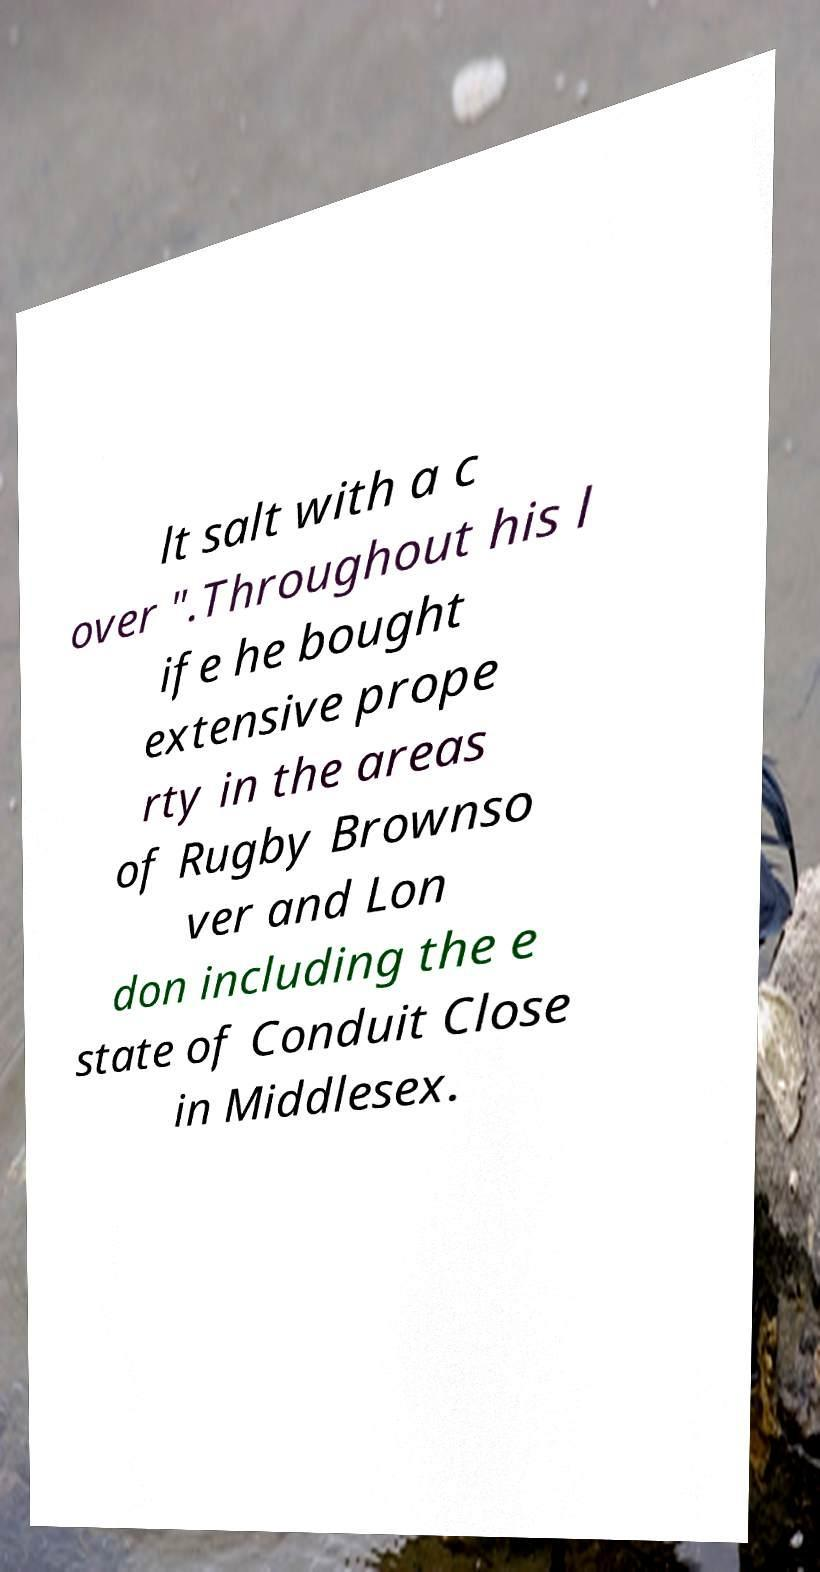For documentation purposes, I need the text within this image transcribed. Could you provide that? lt salt with a c over ".Throughout his l ife he bought extensive prope rty in the areas of Rugby Brownso ver and Lon don including the e state of Conduit Close in Middlesex. 